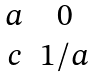<formula> <loc_0><loc_0><loc_500><loc_500>\begin{matrix} a & 0 \\ c & 1 / a \end{matrix}</formula> 